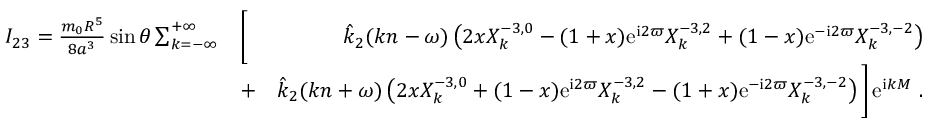Convert formula to latex. <formula><loc_0><loc_0><loc_500><loc_500>\begin{array} { r l r } { I _ { 2 3 } = \frac { m _ { 0 } R ^ { 5 } } { 8 a ^ { 3 } } \sin \theta \sum _ { k = - \infty } ^ { + \infty } } & { \left [ } & { \hat { k } _ { 2 } ( k n - \omega ) \left ( 2 x X _ { k } ^ { - 3 , 0 } - ( 1 + x ) e ^ { i 2 \varpi } X _ { k } ^ { - 3 , 2 } + ( 1 - x ) e ^ { - i 2 \varpi } X _ { k } ^ { - 3 , - 2 } \right ) } \\ & { + } & { \hat { k } _ { 2 } ( k n + \omega ) \left ( 2 x X _ { k } ^ { - 3 , 0 } + ( 1 - x ) e ^ { i 2 \varpi } X _ { k } ^ { - 3 , 2 } - ( 1 + x ) e ^ { - i 2 \varpi } X _ { k } ^ { - 3 , - 2 } \right ) \right ] \, e ^ { i k M } \ . } \end{array}</formula> 